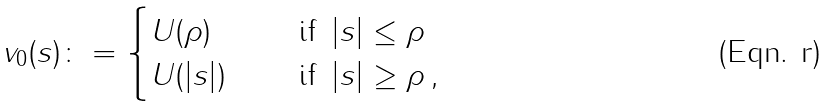Convert formula to latex. <formula><loc_0><loc_0><loc_500><loc_500>v _ { 0 } ( s ) \colon = \begin{cases} U ( \rho ) & \quad \text { if } \, | s | \leq \rho \\ U ( | s | ) & \quad \text { if } \, | s | \geq \rho \, , \end{cases}</formula> 